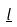Convert formula to latex. <formula><loc_0><loc_0><loc_500><loc_500>\underline { l }</formula> 